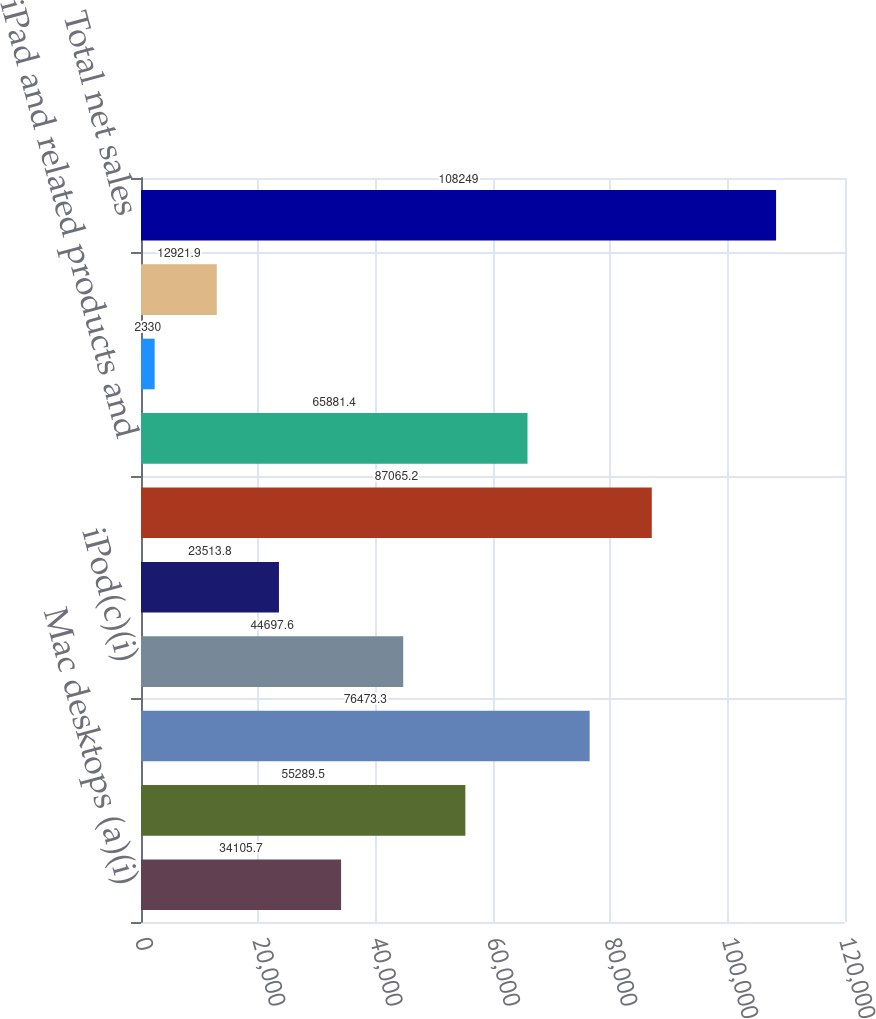Convert chart to OTSL. <chart><loc_0><loc_0><loc_500><loc_500><bar_chart><fcel>Mac desktops (a)(i)<fcel>Mac portables (b)(i)<fcel>Total Mac net sales<fcel>iPod(c)(i)<fcel>Other music related products<fcel>iPhone and related products<fcel>iPad and related products and<fcel>Peripherals and other hardware<fcel>Software service and other net<fcel>Total net sales<nl><fcel>34105.7<fcel>55289.5<fcel>76473.3<fcel>44697.6<fcel>23513.8<fcel>87065.2<fcel>65881.4<fcel>2330<fcel>12921.9<fcel>108249<nl></chart> 